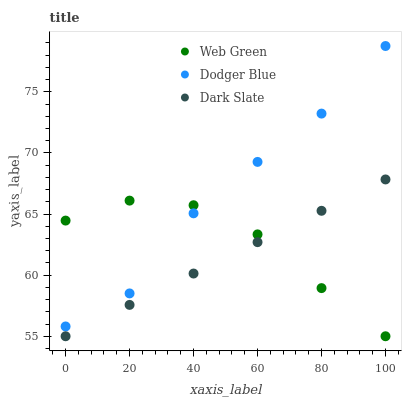Does Dark Slate have the minimum area under the curve?
Answer yes or no. Yes. Does Dodger Blue have the maximum area under the curve?
Answer yes or no. Yes. Does Web Green have the minimum area under the curve?
Answer yes or no. No. Does Web Green have the maximum area under the curve?
Answer yes or no. No. Is Dark Slate the smoothest?
Answer yes or no. Yes. Is Dodger Blue the roughest?
Answer yes or no. Yes. Is Web Green the smoothest?
Answer yes or no. No. Is Web Green the roughest?
Answer yes or no. No. Does Dark Slate have the lowest value?
Answer yes or no. Yes. Does Dodger Blue have the lowest value?
Answer yes or no. No. Does Dodger Blue have the highest value?
Answer yes or no. Yes. Does Web Green have the highest value?
Answer yes or no. No. Is Dark Slate less than Dodger Blue?
Answer yes or no. Yes. Is Dodger Blue greater than Dark Slate?
Answer yes or no. Yes. Does Web Green intersect Dodger Blue?
Answer yes or no. Yes. Is Web Green less than Dodger Blue?
Answer yes or no. No. Is Web Green greater than Dodger Blue?
Answer yes or no. No. Does Dark Slate intersect Dodger Blue?
Answer yes or no. No. 